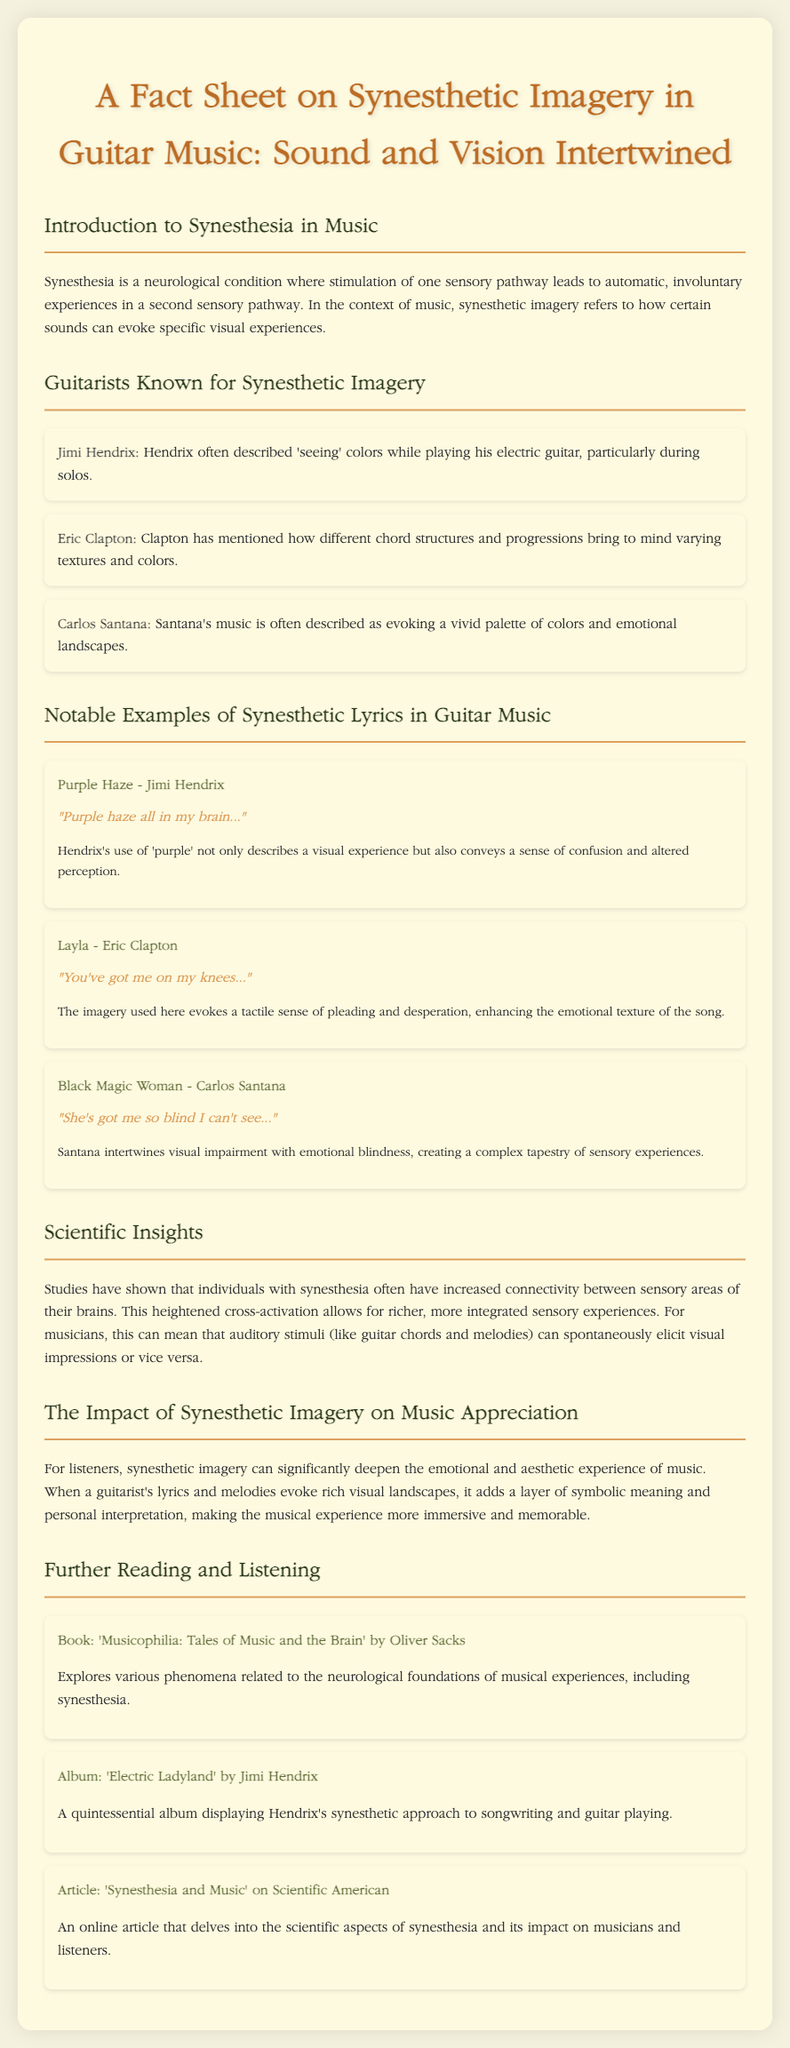What is synesthesia? Synesthesia is described in the document as a neurological condition where stimulation of one sensory pathway leads to automatic, involuntary experiences in a second sensory pathway.
Answer: A neurological condition Who is known for 'seeing' colors while playing guitar? The document lists Jimi Hendrix as a guitarist who often described 'seeing' colors while playing his electric guitar.
Answer: Jimi Hendrix What does Eric Clapton associate with different chord structures? According to the document, Clapton mentioned that different chord structures and progressions bring to mind varying textures and colors.
Answer: Textures and colors What lyric sample is associated with 'Black Magic Woman'? The lyric sample provided in the document for 'Black Magic Woman' is "She's got me so blind I can't see...".
Answer: "She's got me so blind I can't see..." Which book is recommended for further reading on synesthesia? The document recommends 'Musicophilia: Tales of Music and the Brain' by Oliver Sacks for further reading.
Answer: 'Musicophilia: Tales of Music and the Brain' What emotional experience can synesthetic imagery deepen for listeners? The document states that synesthetic imagery can significantly deepen the emotional and aesthetic experience of music.
Answer: Emotional and aesthetic experience How does synesthesia affect a musician's sensory experiences? The document mentions that individuals with synesthesia have increased connectivity between sensory areas of their brains, leading to richer sensory experiences.
Answer: Richer sensory experiences Which album displays Jimi Hendrix's synesthetic approach? The document mentions 'Electric Ladyland' as a quintessential album displaying Hendrix's synesthetic approach to songwriting and guitar playing.
Answer: 'Electric Ladyland' What online article explores the scientific aspects of synesthesia? The document refers to an article titled 'Synesthesia and Music' on Scientific American that delves into the scientific aspects of synesthesia.
Answer: 'Synesthesia and Music' on Scientific American 